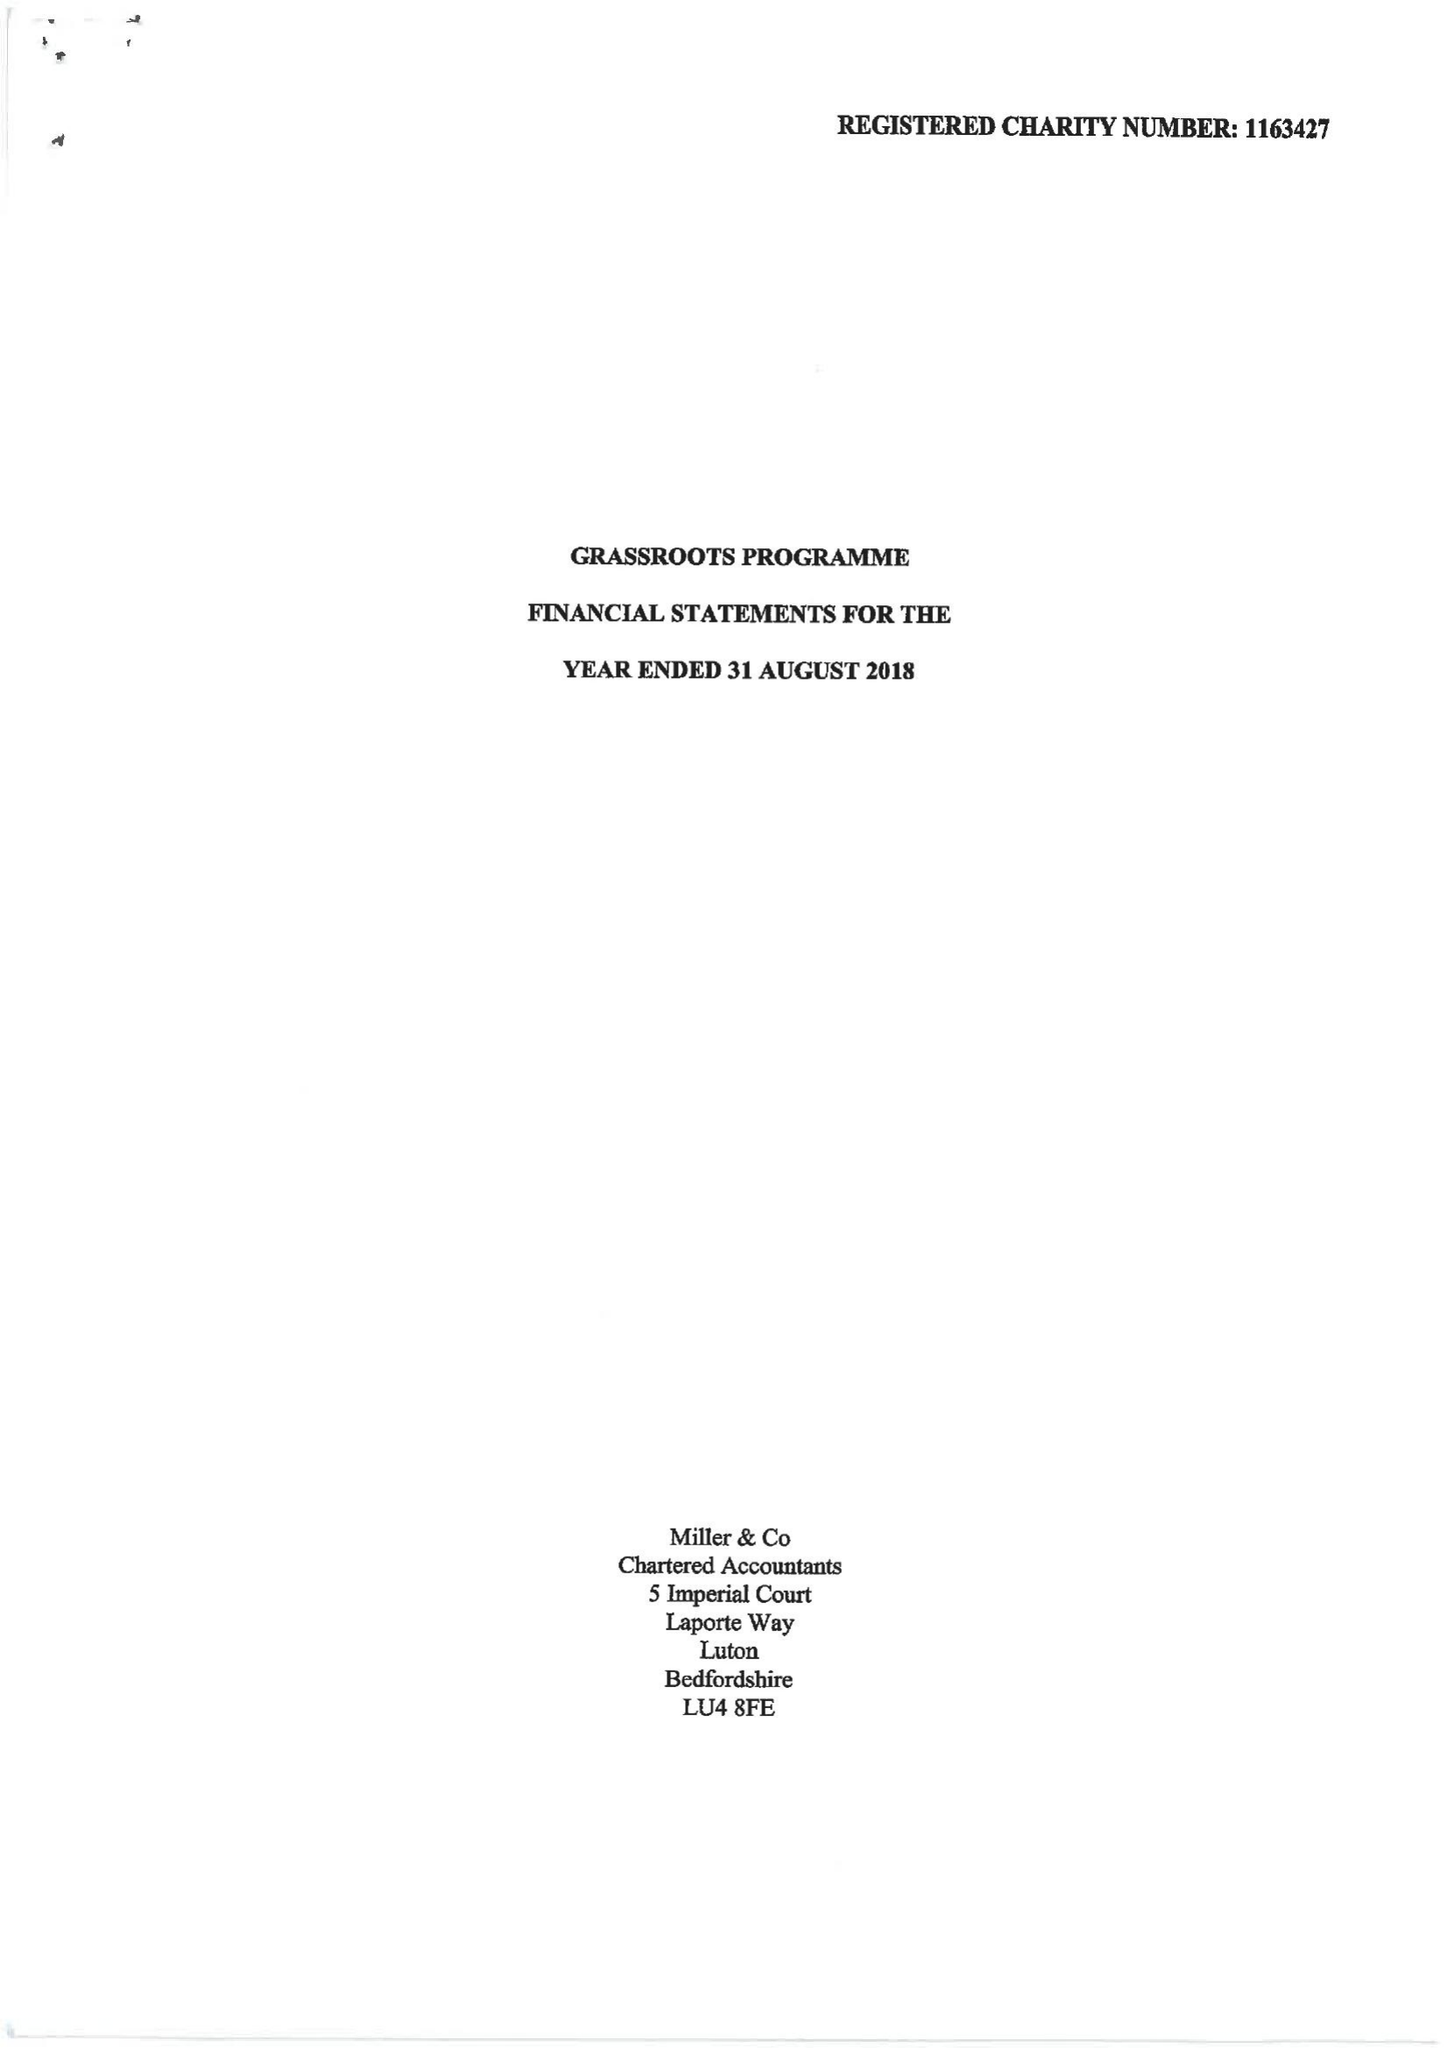What is the value for the spending_annually_in_british_pounds?
Answer the question using a single word or phrase. 179720.00 